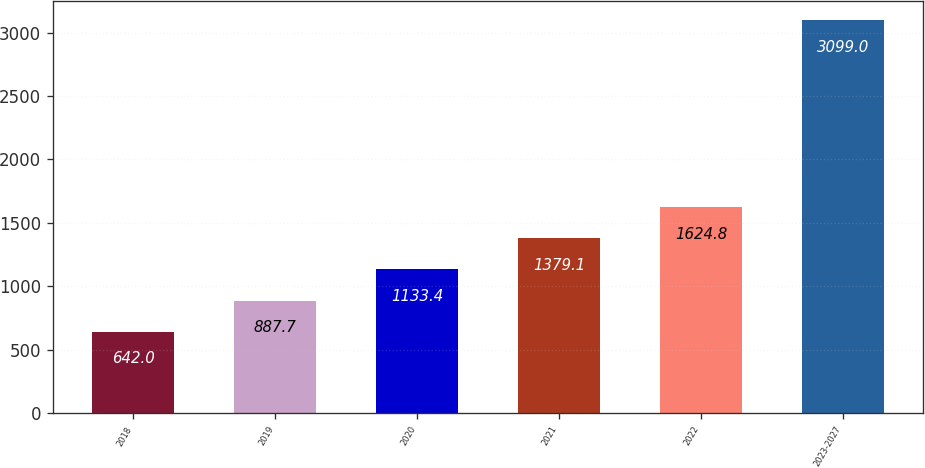<chart> <loc_0><loc_0><loc_500><loc_500><bar_chart><fcel>2018<fcel>2019<fcel>2020<fcel>2021<fcel>2022<fcel>2023-2027<nl><fcel>642<fcel>887.7<fcel>1133.4<fcel>1379.1<fcel>1624.8<fcel>3099<nl></chart> 